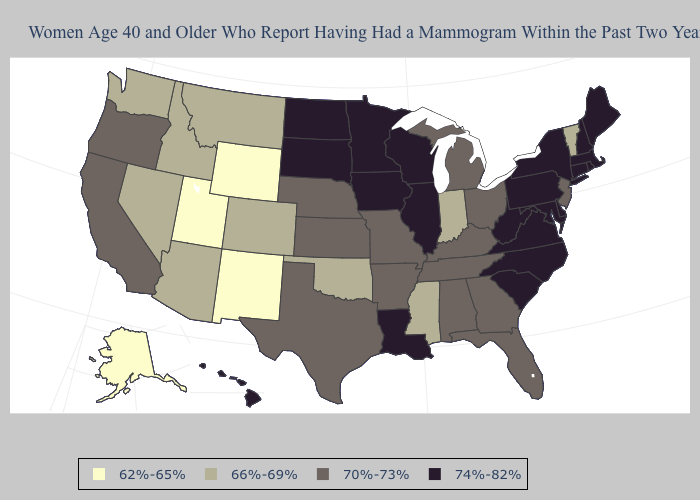Does New Mexico have the highest value in the West?
Be succinct. No. What is the value of Montana?
Give a very brief answer. 66%-69%. Does Alaska have a lower value than North Carolina?
Give a very brief answer. Yes. Does Nebraska have the highest value in the USA?
Short answer required. No. What is the value of Iowa?
Quick response, please. 74%-82%. What is the value of Indiana?
Give a very brief answer. 66%-69%. Does the map have missing data?
Short answer required. No. What is the value of Virginia?
Write a very short answer. 74%-82%. Name the states that have a value in the range 74%-82%?
Write a very short answer. Connecticut, Delaware, Hawaii, Illinois, Iowa, Louisiana, Maine, Maryland, Massachusetts, Minnesota, New Hampshire, New York, North Carolina, North Dakota, Pennsylvania, Rhode Island, South Carolina, South Dakota, Virginia, West Virginia, Wisconsin. What is the lowest value in the MidWest?
Be succinct. 66%-69%. Does North Carolina have the highest value in the USA?
Short answer required. Yes. What is the value of Massachusetts?
Give a very brief answer. 74%-82%. Is the legend a continuous bar?
Short answer required. No. What is the highest value in states that border Arizona?
Write a very short answer. 70%-73%. Among the states that border Ohio , does Pennsylvania have the highest value?
Answer briefly. Yes. 